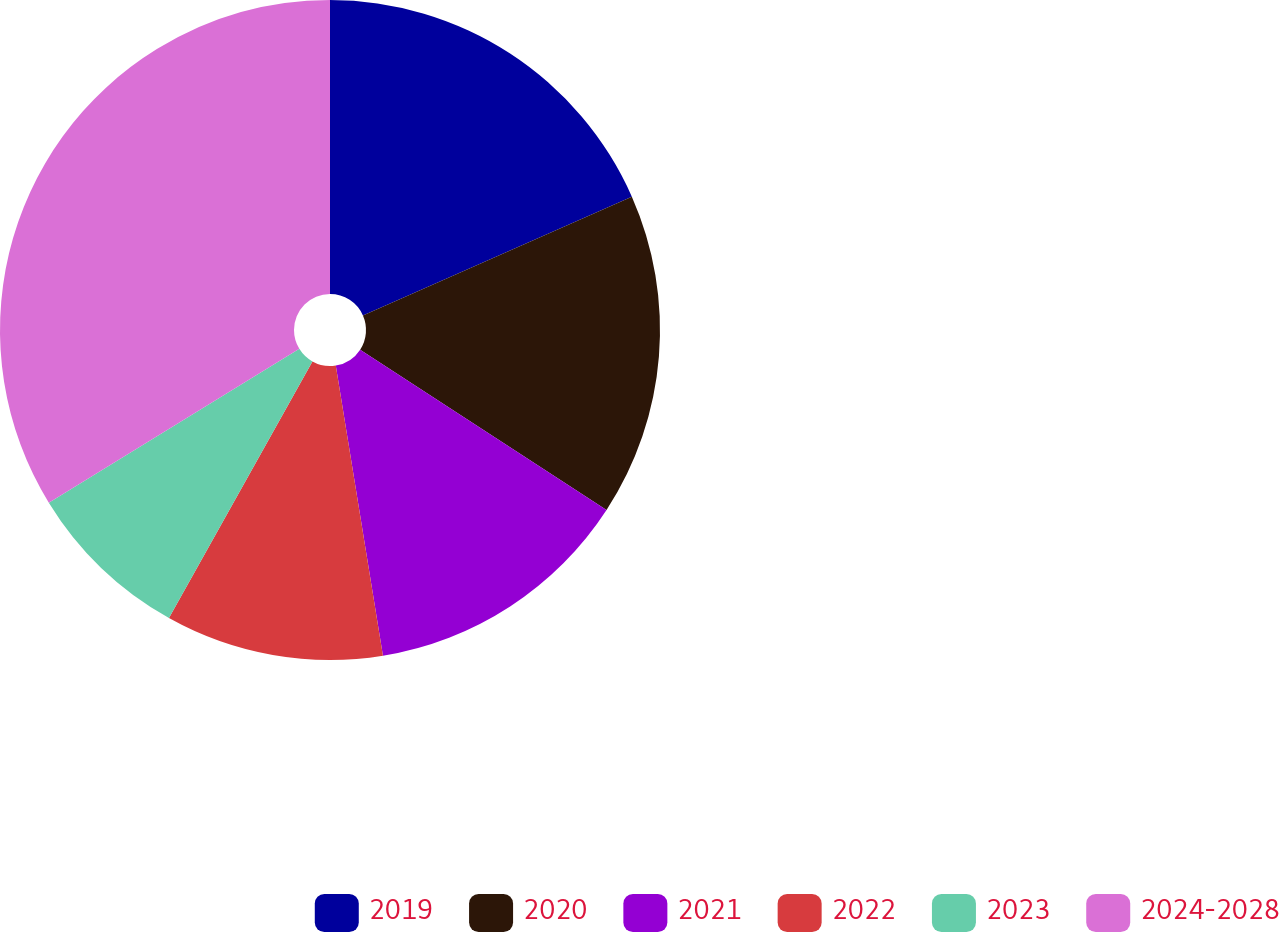Convert chart. <chart><loc_0><loc_0><loc_500><loc_500><pie_chart><fcel>2019<fcel>2020<fcel>2021<fcel>2022<fcel>2023<fcel>2024-2028<nl><fcel>18.38%<fcel>15.81%<fcel>13.25%<fcel>10.68%<fcel>8.12%<fcel>33.77%<nl></chart> 